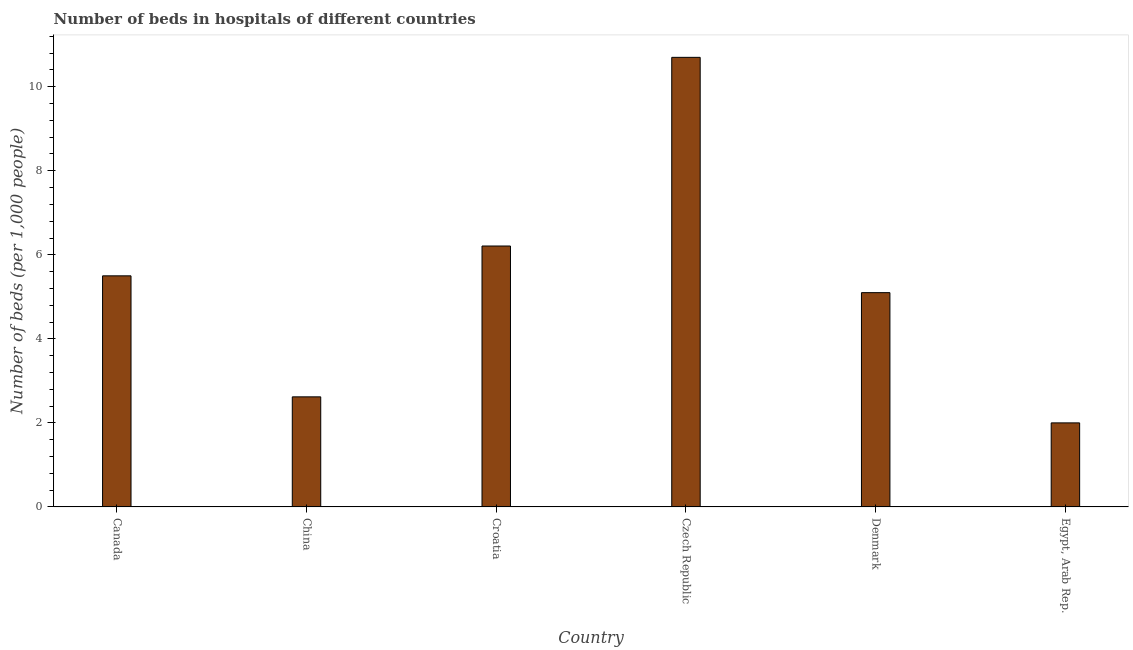Does the graph contain grids?
Give a very brief answer. No. What is the title of the graph?
Your answer should be very brief. Number of beds in hospitals of different countries. What is the label or title of the Y-axis?
Keep it short and to the point. Number of beds (per 1,0 people). What is the number of hospital beds in Denmark?
Your answer should be compact. 5.1. Across all countries, what is the maximum number of hospital beds?
Ensure brevity in your answer.  10.7. Across all countries, what is the minimum number of hospital beds?
Your response must be concise. 2. In which country was the number of hospital beds maximum?
Provide a succinct answer. Czech Republic. In which country was the number of hospital beds minimum?
Your answer should be very brief. Egypt, Arab Rep. What is the sum of the number of hospital beds?
Keep it short and to the point. 32.13. What is the difference between the number of hospital beds in Denmark and Egypt, Arab Rep.?
Keep it short and to the point. 3.1. What is the average number of hospital beds per country?
Give a very brief answer. 5.36. What is the median number of hospital beds?
Offer a very short reply. 5.3. In how many countries, is the number of hospital beds greater than 8.4 %?
Your response must be concise. 1. What is the ratio of the number of hospital beds in Czech Republic to that in Egypt, Arab Rep.?
Offer a very short reply. 5.35. What is the difference between the highest and the second highest number of hospital beds?
Offer a terse response. 4.49. In how many countries, is the number of hospital beds greater than the average number of hospital beds taken over all countries?
Ensure brevity in your answer.  3. Are all the bars in the graph horizontal?
Offer a very short reply. No. How many countries are there in the graph?
Your response must be concise. 6. What is the Number of beds (per 1,000 people) in China?
Your answer should be compact. 2.62. What is the Number of beds (per 1,000 people) in Croatia?
Give a very brief answer. 6.21. What is the Number of beds (per 1,000 people) in Czech Republic?
Ensure brevity in your answer.  10.7. What is the Number of beds (per 1,000 people) of Denmark?
Ensure brevity in your answer.  5.1. What is the Number of beds (per 1,000 people) of Egypt, Arab Rep.?
Offer a very short reply. 2. What is the difference between the Number of beds (per 1,000 people) in Canada and China?
Provide a short and direct response. 2.88. What is the difference between the Number of beds (per 1,000 people) in Canada and Croatia?
Give a very brief answer. -0.71. What is the difference between the Number of beds (per 1,000 people) in Canada and Denmark?
Ensure brevity in your answer.  0.4. What is the difference between the Number of beds (per 1,000 people) in Canada and Egypt, Arab Rep.?
Ensure brevity in your answer.  3.5. What is the difference between the Number of beds (per 1,000 people) in China and Croatia?
Offer a terse response. -3.59. What is the difference between the Number of beds (per 1,000 people) in China and Czech Republic?
Ensure brevity in your answer.  -8.08. What is the difference between the Number of beds (per 1,000 people) in China and Denmark?
Ensure brevity in your answer.  -2.48. What is the difference between the Number of beds (per 1,000 people) in China and Egypt, Arab Rep.?
Your response must be concise. 0.62. What is the difference between the Number of beds (per 1,000 people) in Croatia and Czech Republic?
Your answer should be compact. -4.49. What is the difference between the Number of beds (per 1,000 people) in Croatia and Denmark?
Provide a short and direct response. 1.11. What is the difference between the Number of beds (per 1,000 people) in Croatia and Egypt, Arab Rep.?
Give a very brief answer. 4.21. What is the difference between the Number of beds (per 1,000 people) in Czech Republic and Egypt, Arab Rep.?
Make the answer very short. 8.7. What is the difference between the Number of beds (per 1,000 people) in Denmark and Egypt, Arab Rep.?
Make the answer very short. 3.1. What is the ratio of the Number of beds (per 1,000 people) in Canada to that in China?
Provide a short and direct response. 2.1. What is the ratio of the Number of beds (per 1,000 people) in Canada to that in Croatia?
Provide a short and direct response. 0.89. What is the ratio of the Number of beds (per 1,000 people) in Canada to that in Czech Republic?
Ensure brevity in your answer.  0.51. What is the ratio of the Number of beds (per 1,000 people) in Canada to that in Denmark?
Keep it short and to the point. 1.08. What is the ratio of the Number of beds (per 1,000 people) in Canada to that in Egypt, Arab Rep.?
Give a very brief answer. 2.75. What is the ratio of the Number of beds (per 1,000 people) in China to that in Croatia?
Your response must be concise. 0.42. What is the ratio of the Number of beds (per 1,000 people) in China to that in Czech Republic?
Offer a very short reply. 0.24. What is the ratio of the Number of beds (per 1,000 people) in China to that in Denmark?
Give a very brief answer. 0.51. What is the ratio of the Number of beds (per 1,000 people) in China to that in Egypt, Arab Rep.?
Offer a terse response. 1.31. What is the ratio of the Number of beds (per 1,000 people) in Croatia to that in Czech Republic?
Provide a succinct answer. 0.58. What is the ratio of the Number of beds (per 1,000 people) in Croatia to that in Denmark?
Provide a succinct answer. 1.22. What is the ratio of the Number of beds (per 1,000 people) in Croatia to that in Egypt, Arab Rep.?
Offer a terse response. 3.1. What is the ratio of the Number of beds (per 1,000 people) in Czech Republic to that in Denmark?
Your response must be concise. 2.1. What is the ratio of the Number of beds (per 1,000 people) in Czech Republic to that in Egypt, Arab Rep.?
Offer a terse response. 5.35. What is the ratio of the Number of beds (per 1,000 people) in Denmark to that in Egypt, Arab Rep.?
Your answer should be compact. 2.55. 